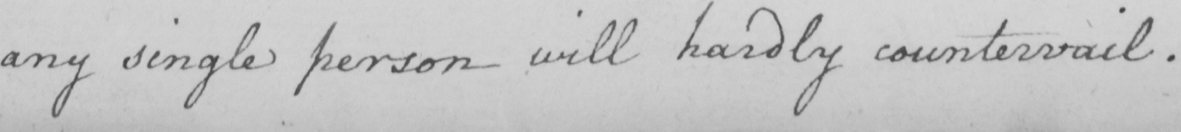What is written in this line of handwriting? any single person will hardly countervail . 